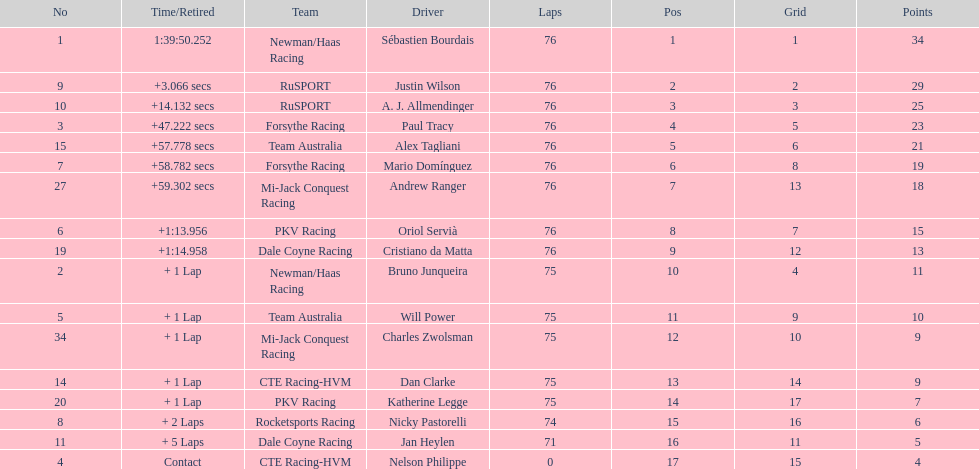Charles zwolsman acquired the same number of points as who? Dan Clarke. 